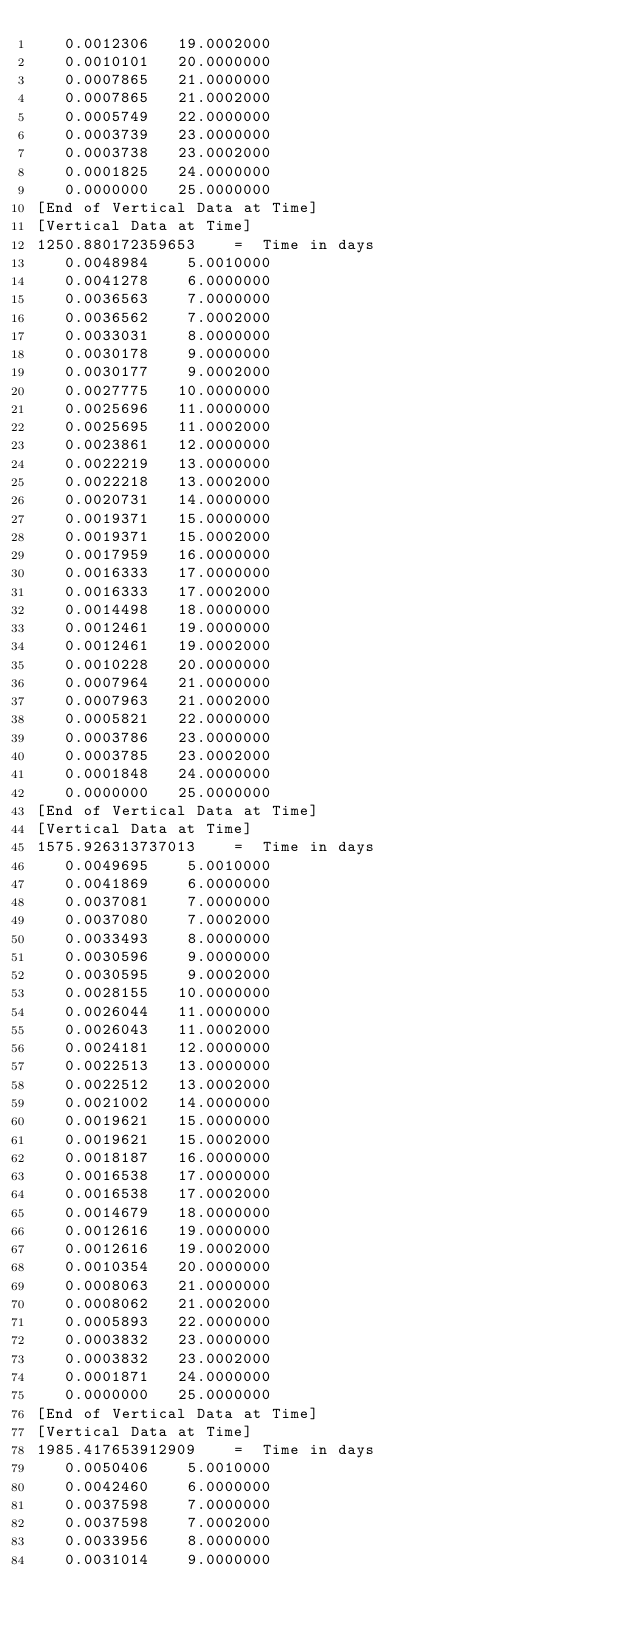Convert code to text. <code><loc_0><loc_0><loc_500><loc_500><_Scheme_>   0.0012306   19.0002000
   0.0010101   20.0000000
   0.0007865   21.0000000
   0.0007865   21.0002000
   0.0005749   22.0000000
   0.0003739   23.0000000
   0.0003738   23.0002000
   0.0001825   24.0000000
   0.0000000   25.0000000
[End of Vertical Data at Time]
[Vertical Data at Time]
1250.880172359653    =  Time in days
   0.0048984    5.0010000
   0.0041278    6.0000000
   0.0036563    7.0000000
   0.0036562    7.0002000
   0.0033031    8.0000000
   0.0030178    9.0000000
   0.0030177    9.0002000
   0.0027775   10.0000000
   0.0025696   11.0000000
   0.0025695   11.0002000
   0.0023861   12.0000000
   0.0022219   13.0000000
   0.0022218   13.0002000
   0.0020731   14.0000000
   0.0019371   15.0000000
   0.0019371   15.0002000
   0.0017959   16.0000000
   0.0016333   17.0000000
   0.0016333   17.0002000
   0.0014498   18.0000000
   0.0012461   19.0000000
   0.0012461   19.0002000
   0.0010228   20.0000000
   0.0007964   21.0000000
   0.0007963   21.0002000
   0.0005821   22.0000000
   0.0003786   23.0000000
   0.0003785   23.0002000
   0.0001848   24.0000000
   0.0000000   25.0000000
[End of Vertical Data at Time]
[Vertical Data at Time]
1575.926313737013    =  Time in days
   0.0049695    5.0010000
   0.0041869    6.0000000
   0.0037081    7.0000000
   0.0037080    7.0002000
   0.0033493    8.0000000
   0.0030596    9.0000000
   0.0030595    9.0002000
   0.0028155   10.0000000
   0.0026044   11.0000000
   0.0026043   11.0002000
   0.0024181   12.0000000
   0.0022513   13.0000000
   0.0022512   13.0002000
   0.0021002   14.0000000
   0.0019621   15.0000000
   0.0019621   15.0002000
   0.0018187   16.0000000
   0.0016538   17.0000000
   0.0016538   17.0002000
   0.0014679   18.0000000
   0.0012616   19.0000000
   0.0012616   19.0002000
   0.0010354   20.0000000
   0.0008063   21.0000000
   0.0008062   21.0002000
   0.0005893   22.0000000
   0.0003832   23.0000000
   0.0003832   23.0002000
   0.0001871   24.0000000
   0.0000000   25.0000000
[End of Vertical Data at Time]
[Vertical Data at Time]
1985.417653912909    =  Time in days
   0.0050406    5.0010000
   0.0042460    6.0000000
   0.0037598    7.0000000
   0.0037598    7.0002000
   0.0033956    8.0000000
   0.0031014    9.0000000</code> 